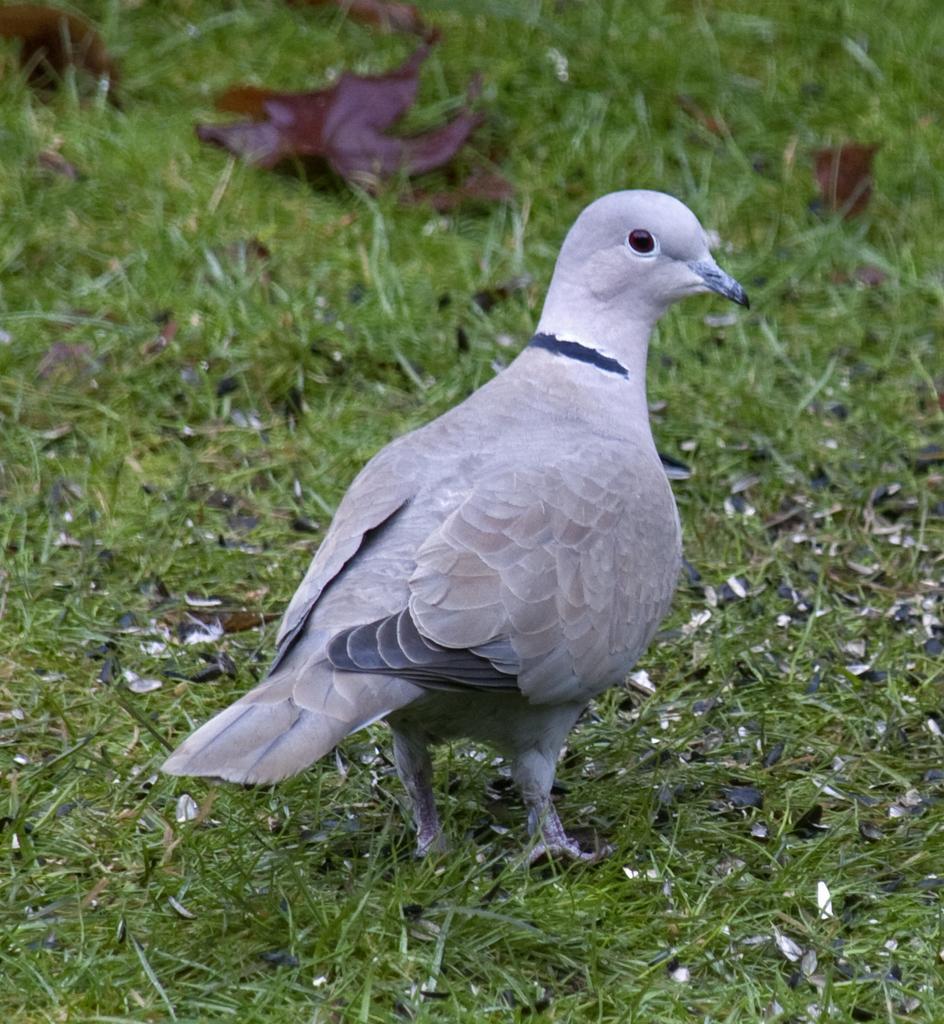Could you give a brief overview of what you see in this image? In the center of the image there is a pigeon. At the bottom we can see grass. 